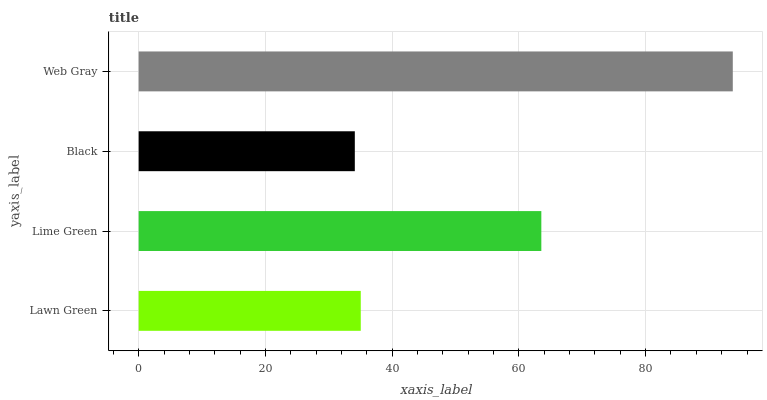Is Black the minimum?
Answer yes or no. Yes. Is Web Gray the maximum?
Answer yes or no. Yes. Is Lime Green the minimum?
Answer yes or no. No. Is Lime Green the maximum?
Answer yes or no. No. Is Lime Green greater than Lawn Green?
Answer yes or no. Yes. Is Lawn Green less than Lime Green?
Answer yes or no. Yes. Is Lawn Green greater than Lime Green?
Answer yes or no. No. Is Lime Green less than Lawn Green?
Answer yes or no. No. Is Lime Green the high median?
Answer yes or no. Yes. Is Lawn Green the low median?
Answer yes or no. Yes. Is Black the high median?
Answer yes or no. No. Is Lime Green the low median?
Answer yes or no. No. 